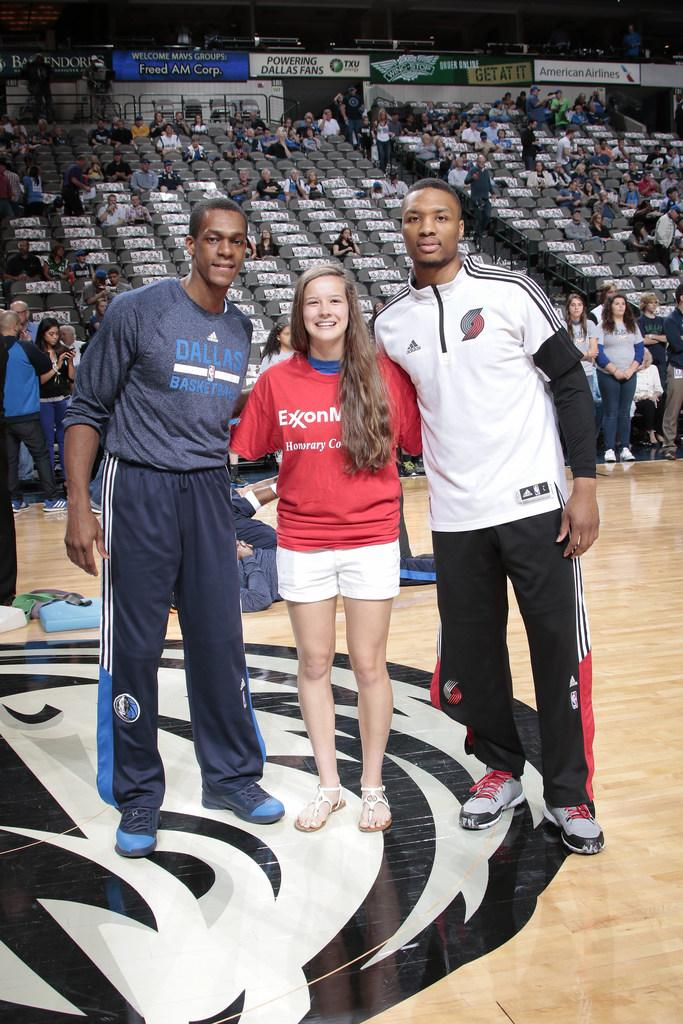<image>
Describe the image concisely. A tall man with a Dallas basketball shirt poses for a photo with two other people. 